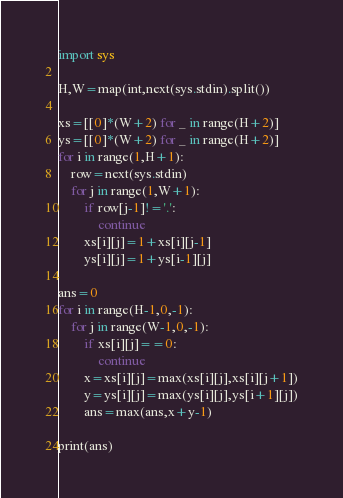<code> <loc_0><loc_0><loc_500><loc_500><_Python_>import sys

H,W=map(int,next(sys.stdin).split())

xs=[[0]*(W+2) for _ in range(H+2)]
ys=[[0]*(W+2) for _ in range(H+2)]
for i in range(1,H+1):
    row=next(sys.stdin)
    for j in range(1,W+1):
        if row[j-1]!='.':
            continue
        xs[i][j]=1+xs[i][j-1]
        ys[i][j]=1+ys[i-1][j]

ans=0
for i in range(H-1,0,-1):
    for j in range(W-1,0,-1):
        if xs[i][j]==0:
            continue
        x=xs[i][j]=max(xs[i][j],xs[i][j+1])
        y=ys[i][j]=max(ys[i][j],ys[i+1][j])
        ans=max(ans,x+y-1)

print(ans)
</code> 